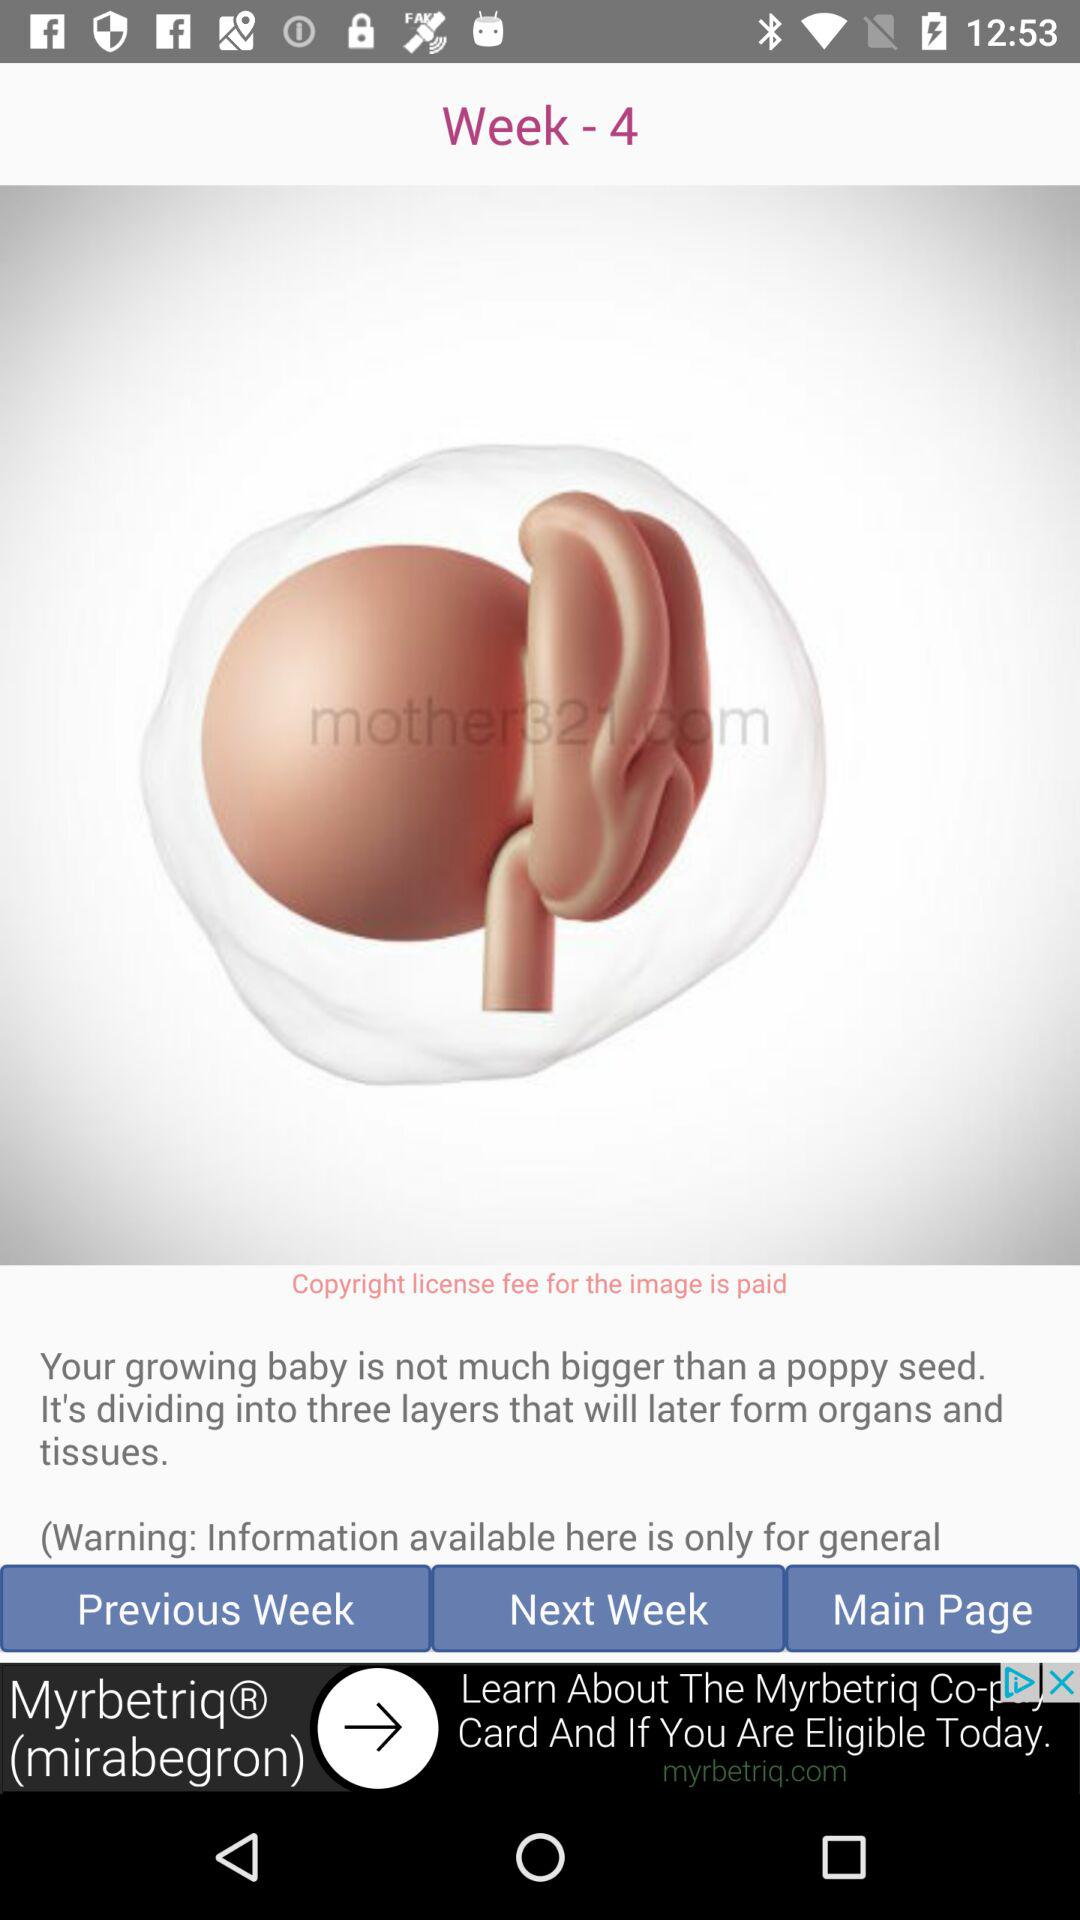How many layers will your growing baby form?
Answer the question using a single word or phrase. 3 